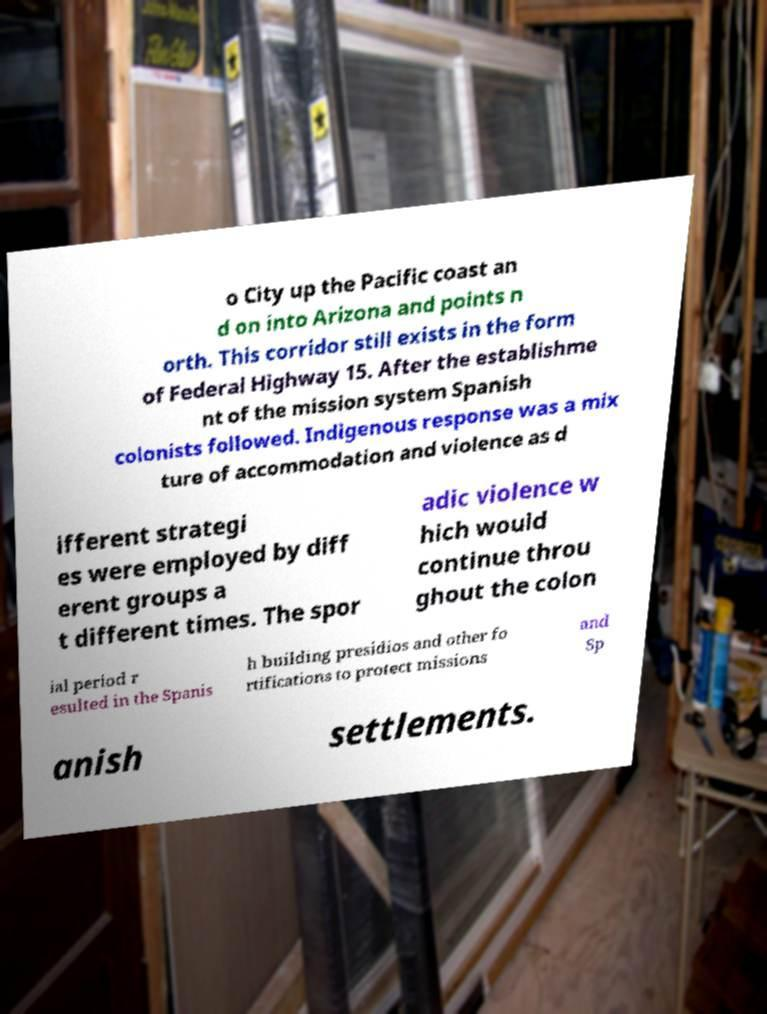Please identify and transcribe the text found in this image. o City up the Pacific coast an d on into Arizona and points n orth. This corridor still exists in the form of Federal Highway 15. After the establishme nt of the mission system Spanish colonists followed. Indigenous response was a mix ture of accommodation and violence as d ifferent strategi es were employed by diff erent groups a t different times. The spor adic violence w hich would continue throu ghout the colon ial period r esulted in the Spanis h building presidios and other fo rtifications to protect missions and Sp anish settlements. 